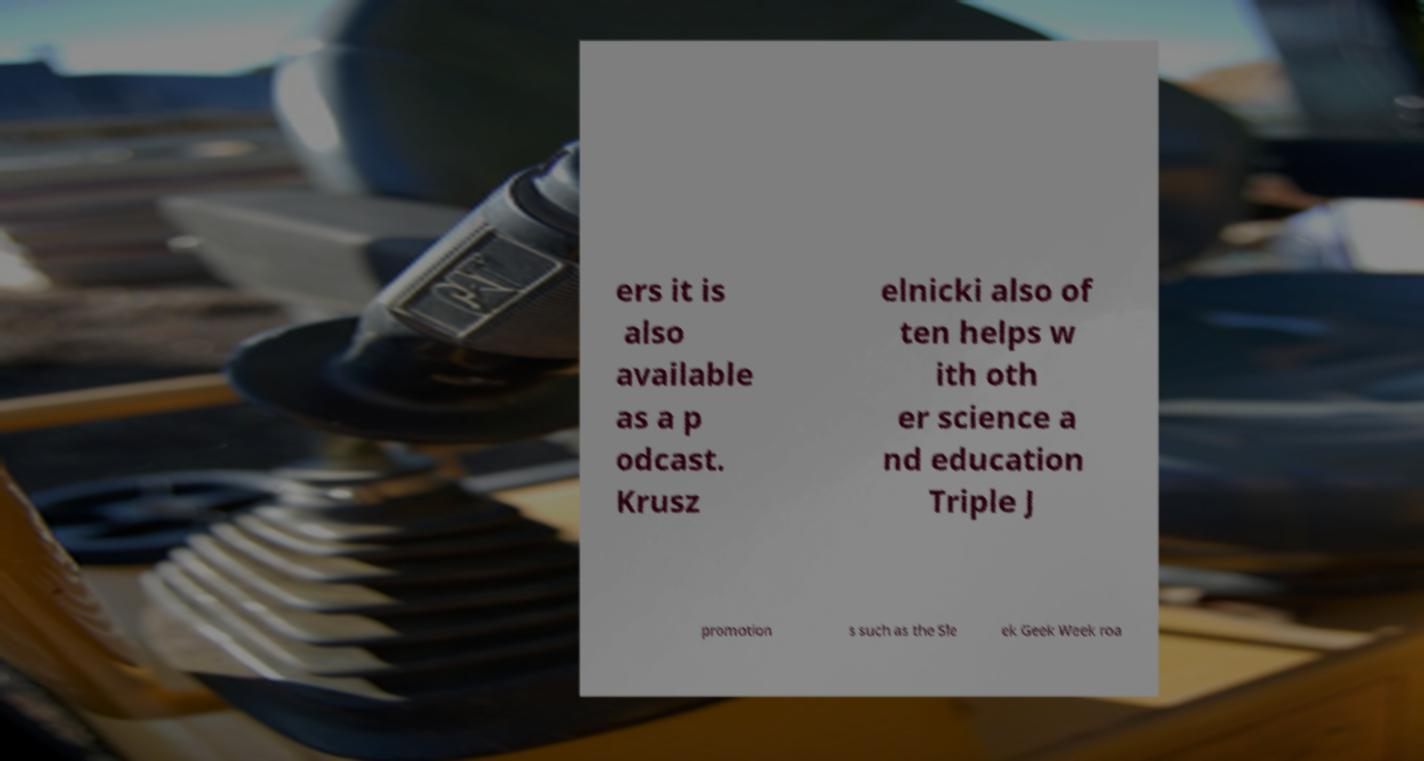For documentation purposes, I need the text within this image transcribed. Could you provide that? ers it is also available as a p odcast. Krusz elnicki also of ten helps w ith oth er science a nd education Triple J promotion s such as the Sle ek Geek Week roa 